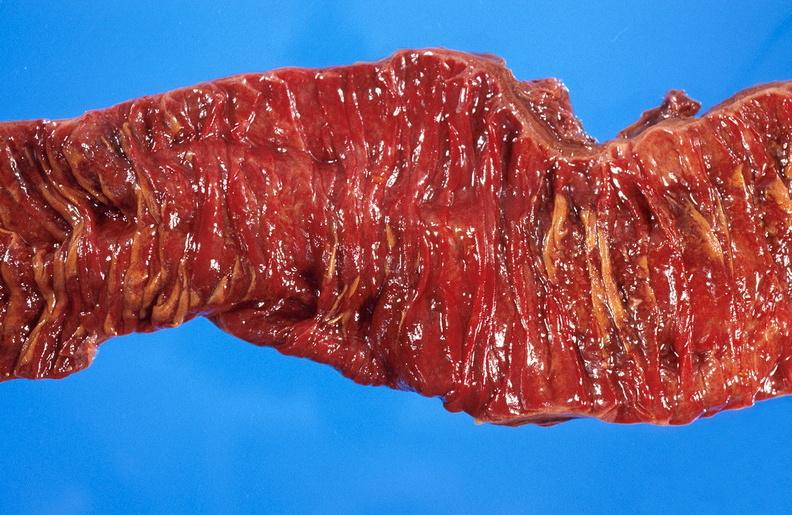s gastrointestinal present?
Answer the question using a single word or phrase. Yes 